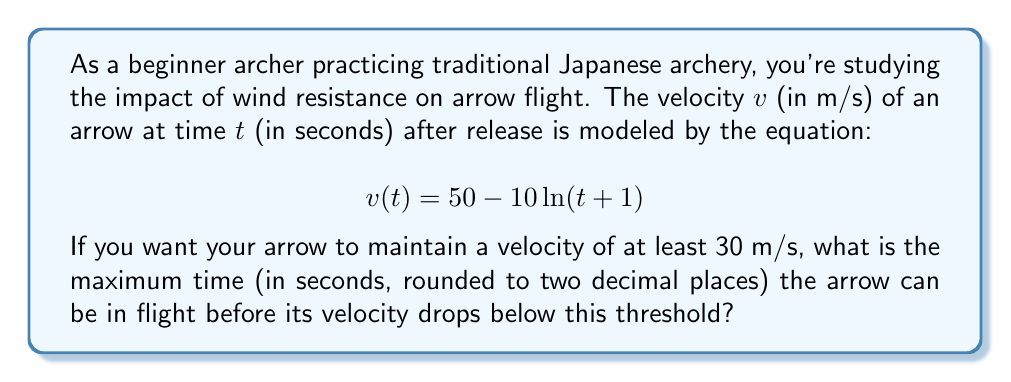Could you help me with this problem? Let's approach this step-by-step:

1) We need to find the time $t$ when the velocity $v(t)$ equals 30 m/s. This can be expressed as:

   $$30 = 50 - 10 \ln(t + 1)$$

2) Subtract 50 from both sides:

   $$-20 = -10 \ln(t + 1)$$

3) Divide both sides by -10:

   $$2 = \ln(t + 1)$$

4) To solve for $t$, we need to apply the exponential function (e^) to both sides:

   $$e^2 = e^{\ln(t + 1)}$$

5) The left side simplifies to $e^2$, and on the right side, $e$ and $\ln$ cancel out:

   $$e^2 = t + 1$$

6) Subtract 1 from both sides:

   $$e^2 - 1 = t$$

7) Calculate $e^2$ and subtract 1:

   $$t \approx 7.3891 - 1 = 6.3891$$

8) Rounding to two decimal places:

   $$t \approx 6.39 \text{ seconds}$$

Therefore, the arrow can maintain a velocity of at least 30 m/s for approximately 6.39 seconds.
Answer: 6.39 seconds 